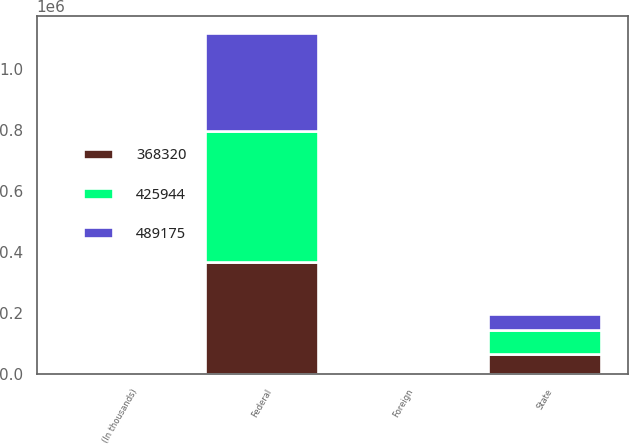Convert chart to OTSL. <chart><loc_0><loc_0><loc_500><loc_500><stacked_bar_chart><ecel><fcel>(In thousands)<fcel>Federal<fcel>Foreign<fcel>State<nl><fcel>368320<fcel>2019<fcel>368451<fcel>102<fcel>65215<nl><fcel>489175<fcel>2018<fcel>320361<fcel>159<fcel>53091<nl><fcel>425944<fcel>2017<fcel>426933<fcel>105<fcel>79011<nl></chart> 